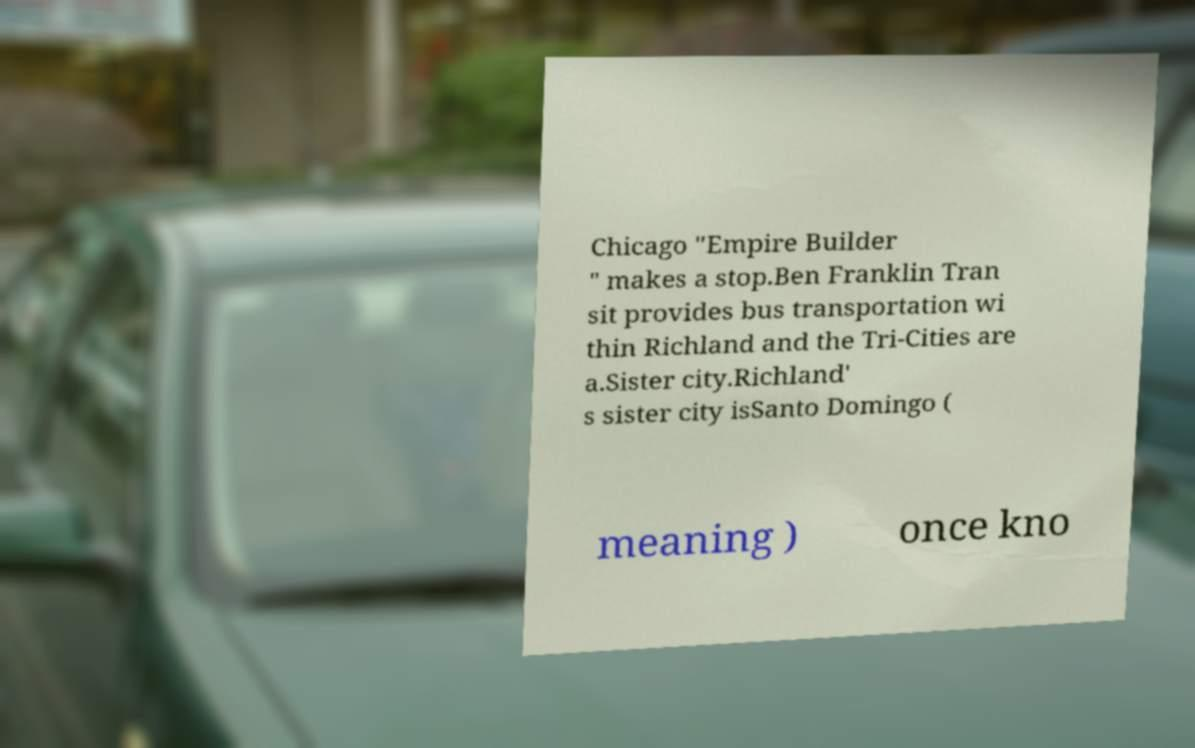Could you extract and type out the text from this image? Chicago "Empire Builder " makes a stop.Ben Franklin Tran sit provides bus transportation wi thin Richland and the Tri-Cities are a.Sister city.Richland' s sister city isSanto Domingo ( meaning ) once kno 